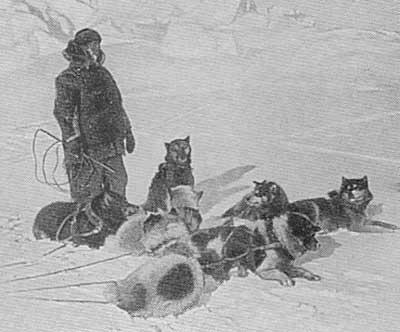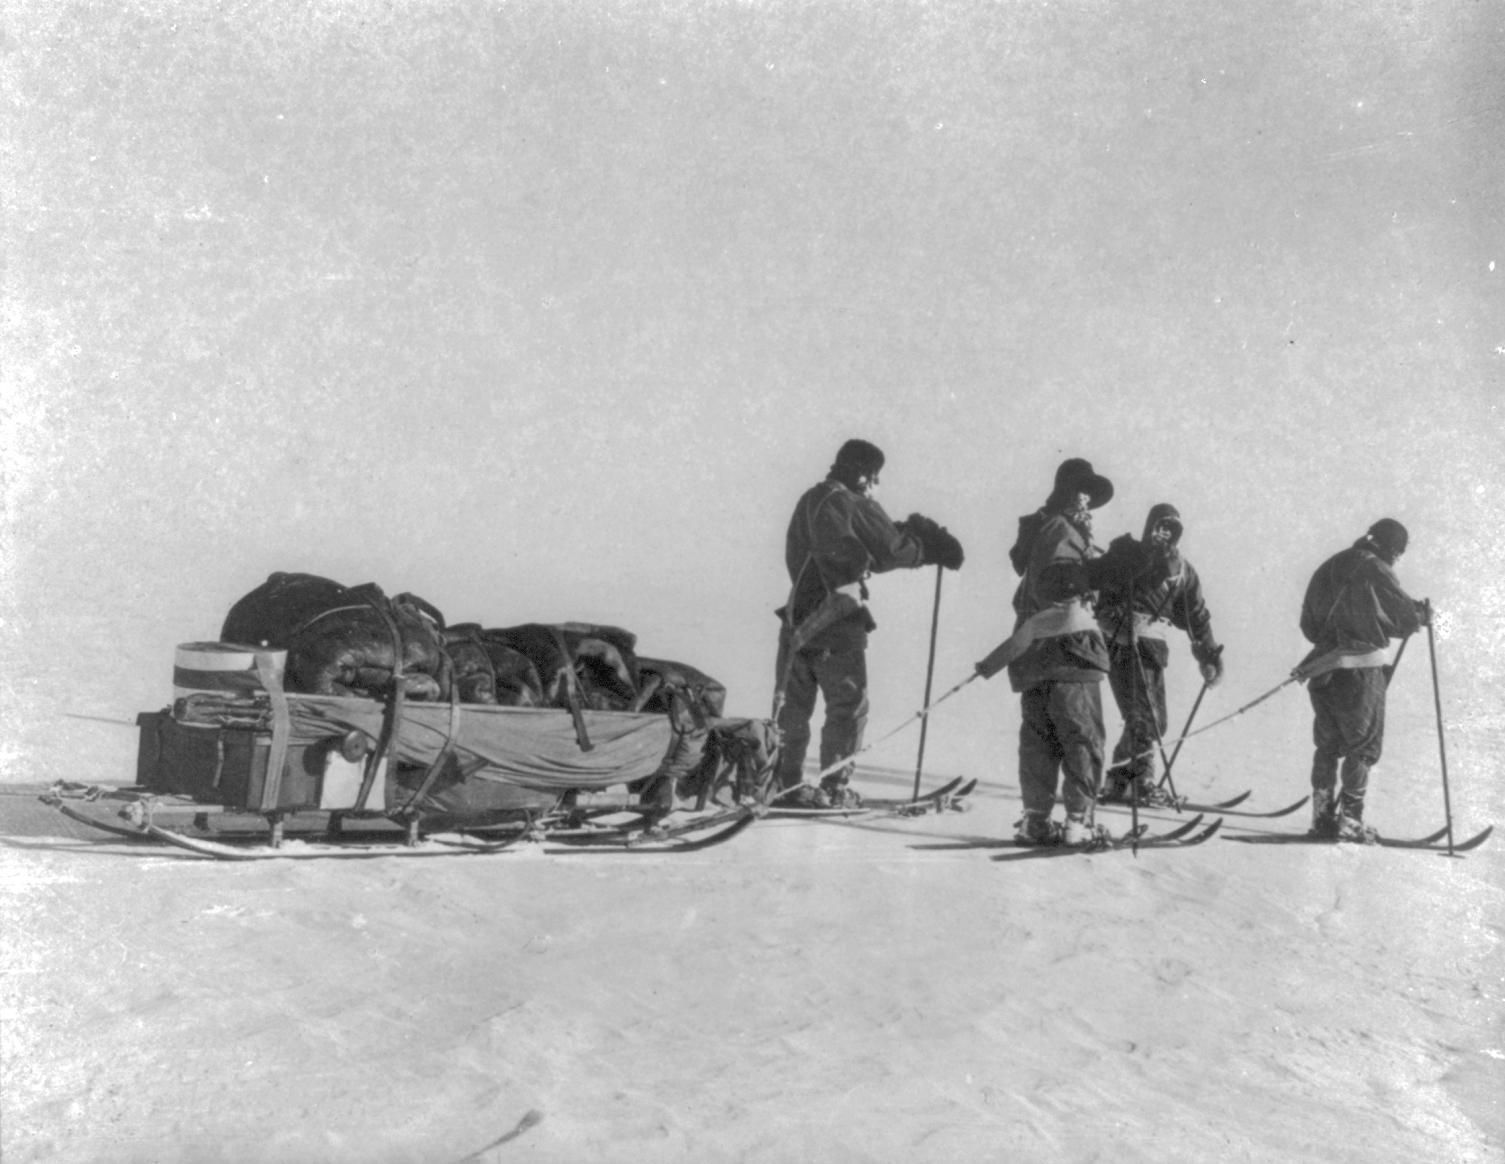The first image is the image on the left, the second image is the image on the right. Given the left and right images, does the statement "One image shows a team of rope-hitched dogs resting on the snow, with no sled or any landmarks in sight and with at least some dogs reclining." hold true? Answer yes or no. Yes. The first image is the image on the left, the second image is the image on the right. Analyze the images presented: Is the assertion "A pack of dogs is standing in the snow near a building in the image on the left." valid? Answer yes or no. No. 